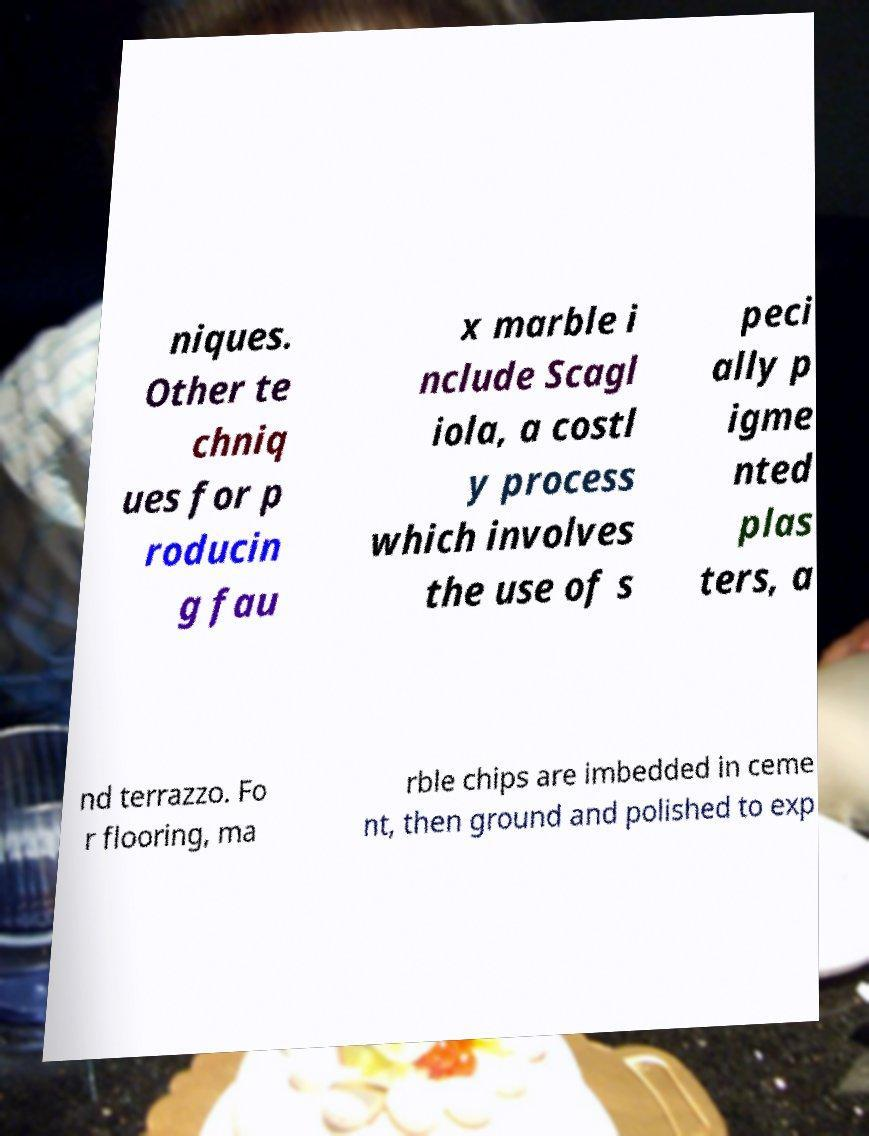For documentation purposes, I need the text within this image transcribed. Could you provide that? niques. Other te chniq ues for p roducin g fau x marble i nclude Scagl iola, a costl y process which involves the use of s peci ally p igme nted plas ters, a nd terrazzo. Fo r flooring, ma rble chips are imbedded in ceme nt, then ground and polished to exp 